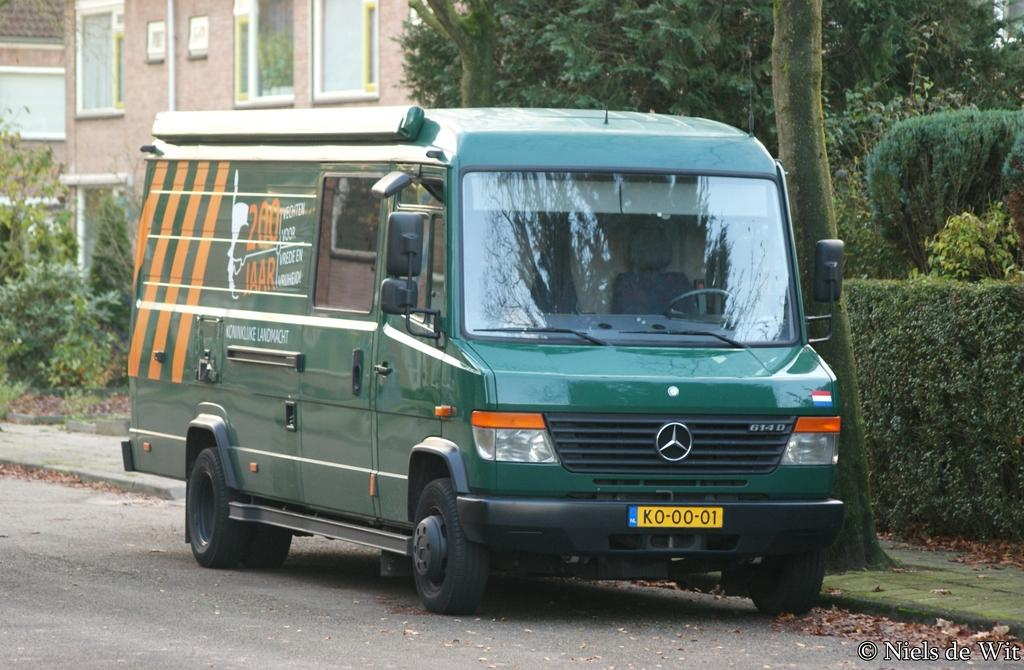What is parked on the road in the image? There is a vehicle parked on the road in the image. What can be seen in the distance behind the vehicle? There are buildings, trees, bushes, and shrubs in the background of the image. What type of vegetation is present in the background of the image? Trees, bushes, and shrubs are present in the background of the image. What additional detail can be observed on the ground in the image? Dried leaves are observable in the image. What type of food is being prepared in the vehicle in the image? There is no food preparation visible in the image; it only shows a parked vehicle. Where is the pocket located on the vehicle in the image? There is no pocket present on the vehicle in the image. 